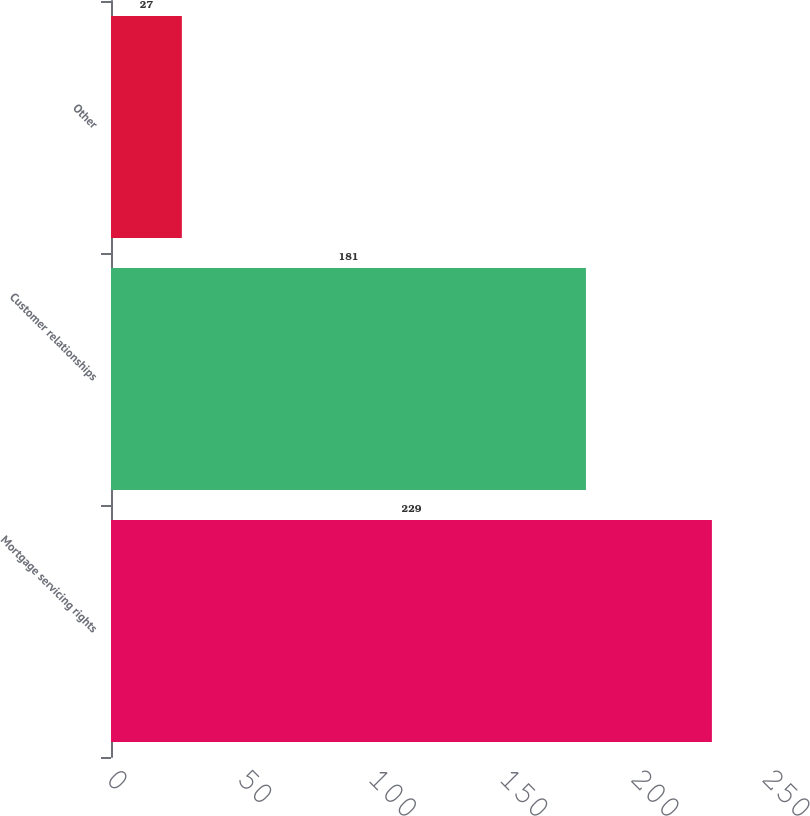<chart> <loc_0><loc_0><loc_500><loc_500><bar_chart><fcel>Mortgage servicing rights<fcel>Customer relationships<fcel>Other<nl><fcel>229<fcel>181<fcel>27<nl></chart> 